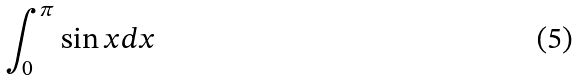Convert formula to latex. <formula><loc_0><loc_0><loc_500><loc_500>\int _ { 0 } ^ { \pi } \sin x d x</formula> 